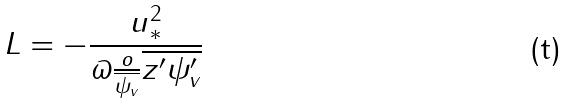Convert formula to latex. <formula><loc_0><loc_0><loc_500><loc_500>L = - \frac { u _ { * } ^ { 2 } } { \varpi \frac { o } { \overline { \psi _ { v } } } \overline { z ^ { \prime } \psi _ { v } ^ { \prime } } }</formula> 